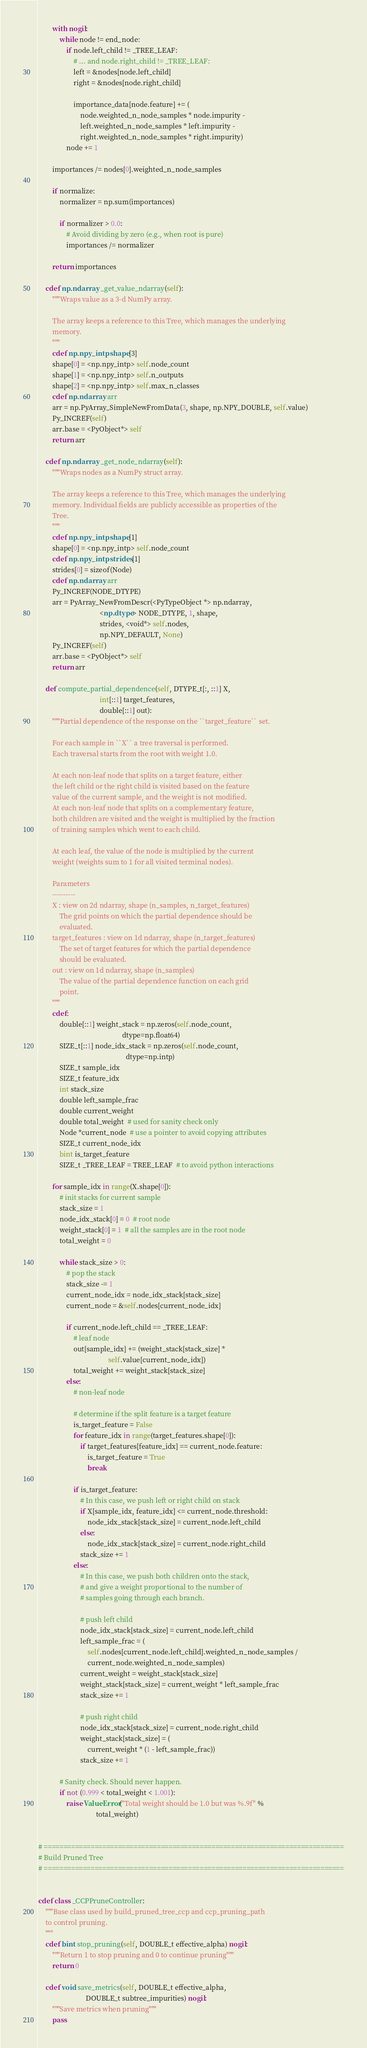Convert code to text. <code><loc_0><loc_0><loc_500><loc_500><_Cython_>        with nogil:
            while node != end_node:
                if node.left_child != _TREE_LEAF:
                    # ... and node.right_child != _TREE_LEAF:
                    left = &nodes[node.left_child]
                    right = &nodes[node.right_child]

                    importance_data[node.feature] += (
                        node.weighted_n_node_samples * node.impurity -
                        left.weighted_n_node_samples * left.impurity -
                        right.weighted_n_node_samples * right.impurity)
                node += 1

        importances /= nodes[0].weighted_n_node_samples

        if normalize:
            normalizer = np.sum(importances)

            if normalizer > 0.0:
                # Avoid dividing by zero (e.g., when root is pure)
                importances /= normalizer

        return importances

    cdef np.ndarray _get_value_ndarray(self):
        """Wraps value as a 3-d NumPy array.

        The array keeps a reference to this Tree, which manages the underlying
        memory.
        """
        cdef np.npy_intp shape[3]
        shape[0] = <np.npy_intp> self.node_count
        shape[1] = <np.npy_intp> self.n_outputs
        shape[2] = <np.npy_intp> self.max_n_classes
        cdef np.ndarray arr
        arr = np.PyArray_SimpleNewFromData(3, shape, np.NPY_DOUBLE, self.value)
        Py_INCREF(self)
        arr.base = <PyObject*> self
        return arr

    cdef np.ndarray _get_node_ndarray(self):
        """Wraps nodes as a NumPy struct array.

        The array keeps a reference to this Tree, which manages the underlying
        memory. Individual fields are publicly accessible as properties of the
        Tree.
        """
        cdef np.npy_intp shape[1]
        shape[0] = <np.npy_intp> self.node_count
        cdef np.npy_intp strides[1]
        strides[0] = sizeof(Node)
        cdef np.ndarray arr
        Py_INCREF(NODE_DTYPE)
        arr = PyArray_NewFromDescr(<PyTypeObject *> np.ndarray,
                                   <np.dtype> NODE_DTYPE, 1, shape,
                                   strides, <void*> self.nodes,
                                   np.NPY_DEFAULT, None)
        Py_INCREF(self)
        arr.base = <PyObject*> self
        return arr

    def compute_partial_dependence(self, DTYPE_t[:, ::1] X,
                                   int[::1] target_features,
                                   double[::1] out):
        """Partial dependence of the response on the ``target_feature`` set.

        For each sample in ``X`` a tree traversal is performed.
        Each traversal starts from the root with weight 1.0.

        At each non-leaf node that splits on a target feature, either
        the left child or the right child is visited based on the feature
        value of the current sample, and the weight is not modified.
        At each non-leaf node that splits on a complementary feature,
        both children are visited and the weight is multiplied by the fraction
        of training samples which went to each child.

        At each leaf, the value of the node is multiplied by the current
        weight (weights sum to 1 for all visited terminal nodes).

        Parameters
        ----------
        X : view on 2d ndarray, shape (n_samples, n_target_features)
            The grid points on which the partial dependence should be
            evaluated.
        target_features : view on 1d ndarray, shape (n_target_features)
            The set of target features for which the partial dependence
            should be evaluated.
        out : view on 1d ndarray, shape (n_samples)
            The value of the partial dependence function on each grid
            point.
        """
        cdef:
            double[::1] weight_stack = np.zeros(self.node_count,
                                                dtype=np.float64)
            SIZE_t[::1] node_idx_stack = np.zeros(self.node_count,
                                                  dtype=np.intp)
            SIZE_t sample_idx
            SIZE_t feature_idx
            int stack_size
            double left_sample_frac
            double current_weight
            double total_weight  # used for sanity check only
            Node *current_node  # use a pointer to avoid copying attributes
            SIZE_t current_node_idx
            bint is_target_feature
            SIZE_t _TREE_LEAF = TREE_LEAF  # to avoid python interactions

        for sample_idx in range(X.shape[0]):
            # init stacks for current sample
            stack_size = 1
            node_idx_stack[0] = 0  # root node
            weight_stack[0] = 1  # all the samples are in the root node
            total_weight = 0

            while stack_size > 0:
                # pop the stack
                stack_size -= 1
                current_node_idx = node_idx_stack[stack_size]
                current_node = &self.nodes[current_node_idx]

                if current_node.left_child == _TREE_LEAF:
                    # leaf node
                    out[sample_idx] += (weight_stack[stack_size] *
                                        self.value[current_node_idx])
                    total_weight += weight_stack[stack_size]
                else:
                    # non-leaf node

                    # determine if the split feature is a target feature
                    is_target_feature = False
                    for feature_idx in range(target_features.shape[0]):
                        if target_features[feature_idx] == current_node.feature:
                            is_target_feature = True
                            break

                    if is_target_feature:
                        # In this case, we push left or right child on stack
                        if X[sample_idx, feature_idx] <= current_node.threshold:
                            node_idx_stack[stack_size] = current_node.left_child
                        else:
                            node_idx_stack[stack_size] = current_node.right_child
                        stack_size += 1
                    else:
                        # In this case, we push both children onto the stack,
                        # and give a weight proportional to the number of
                        # samples going through each branch.

                        # push left child
                        node_idx_stack[stack_size] = current_node.left_child
                        left_sample_frac = (
                            self.nodes[current_node.left_child].weighted_n_node_samples /
                            current_node.weighted_n_node_samples)
                        current_weight = weight_stack[stack_size]
                        weight_stack[stack_size] = current_weight * left_sample_frac
                        stack_size += 1

                        # push right child
                        node_idx_stack[stack_size] = current_node.right_child
                        weight_stack[stack_size] = (
                            current_weight * (1 - left_sample_frac))
                        stack_size += 1

            # Sanity check. Should never happen.
            if not (0.999 < total_weight < 1.001):
                raise ValueError("Total weight should be 1.0 but was %.9f" %
                                 total_weight)


# =============================================================================
# Build Pruned Tree
# =============================================================================


cdef class _CCPPruneController:
    """Base class used by build_pruned_tree_ccp and ccp_pruning_path
    to control pruning.
    """
    cdef bint stop_pruning(self, DOUBLE_t effective_alpha) nogil:
        """Return 1 to stop pruning and 0 to continue pruning"""
        return 0

    cdef void save_metrics(self, DOUBLE_t effective_alpha,
                           DOUBLE_t subtree_impurities) nogil:
        """Save metrics when pruning"""
        pass
</code> 